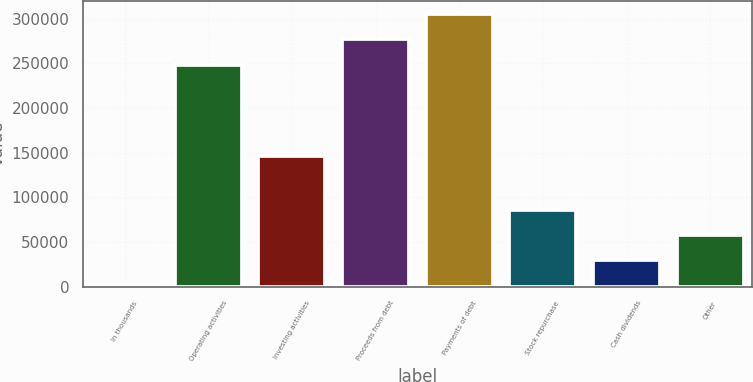Convert chart to OTSL. <chart><loc_0><loc_0><loc_500><loc_500><bar_chart><fcel>In thousands<fcel>Operating activities<fcel>Investing activities<fcel>Proceeds from debt<fcel>Payments of debt<fcel>Stock repurchase<fcel>Cash dividends<fcel>Other<nl><fcel>2011<fcel>248626<fcel>146182<fcel>276745<fcel>304864<fcel>86368.3<fcel>30130.1<fcel>58249.2<nl></chart> 